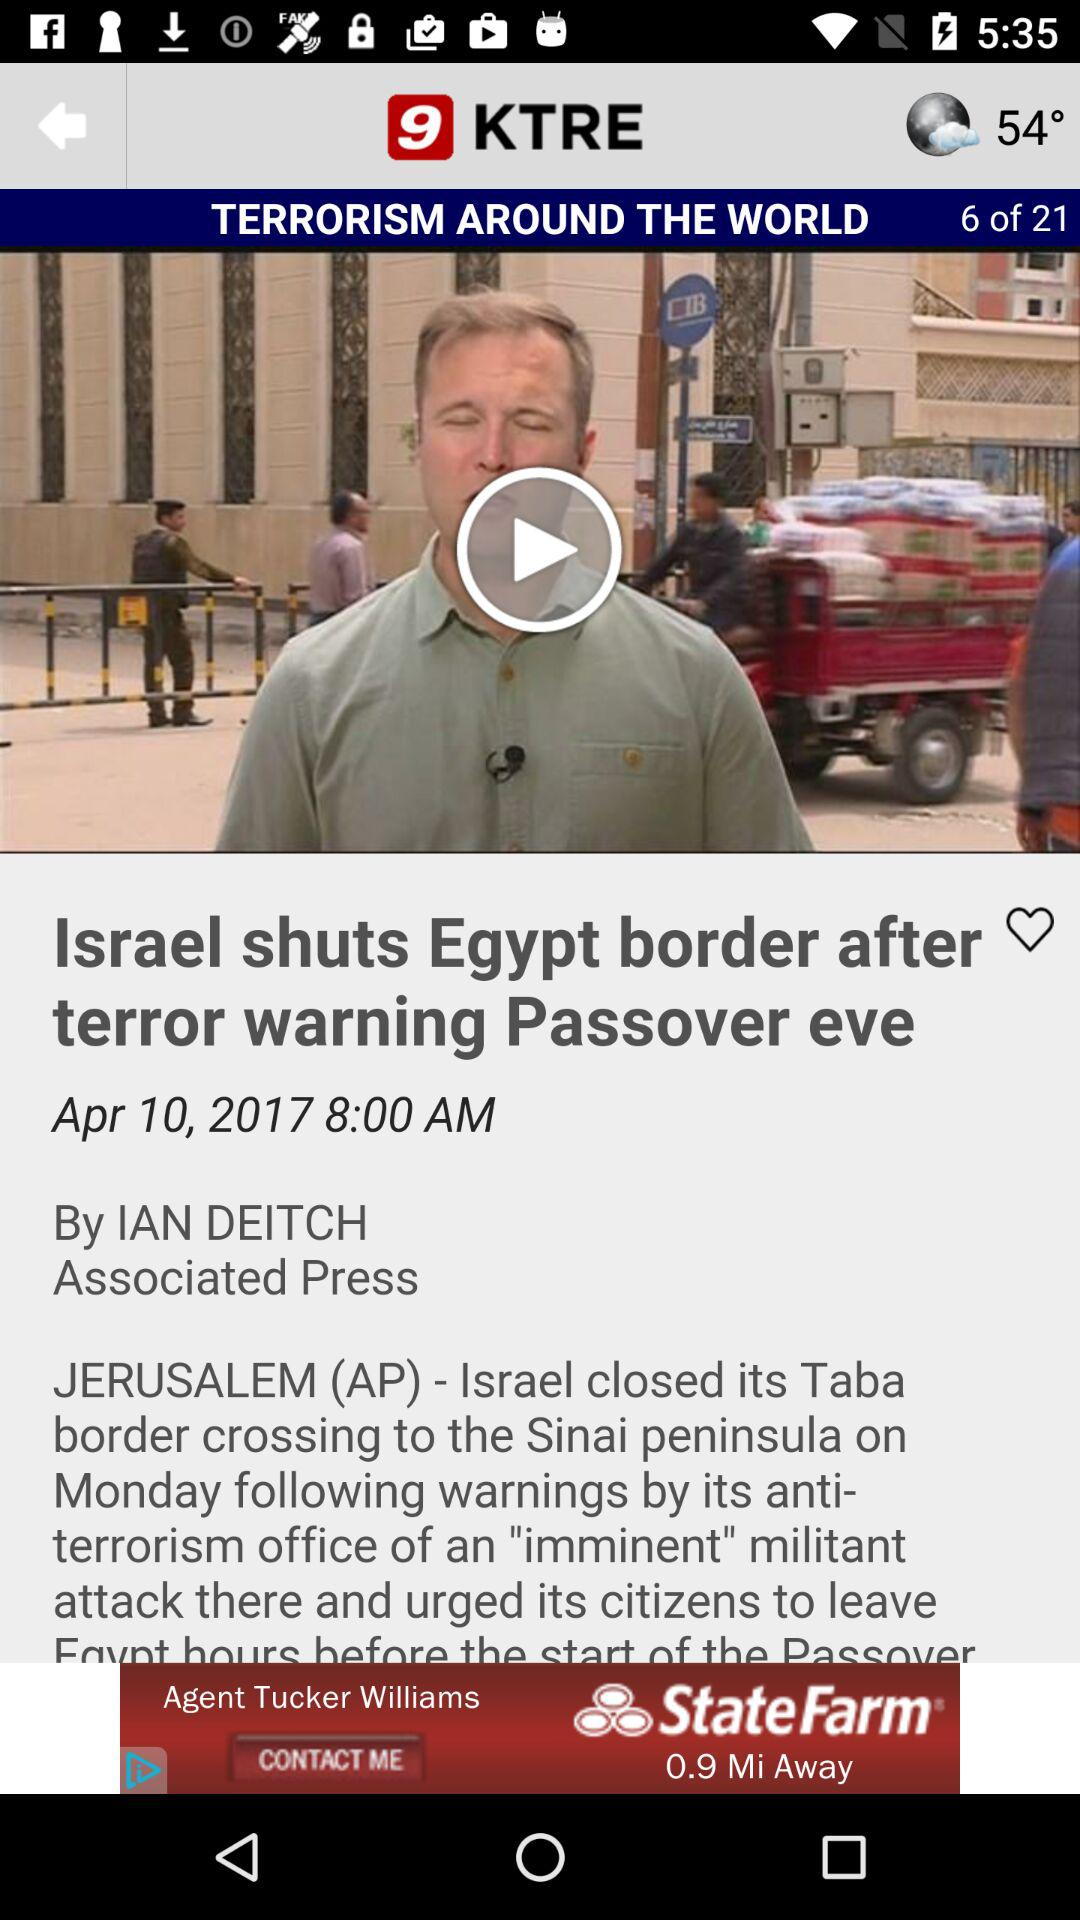What is the temperature? The temperature is 54°. 